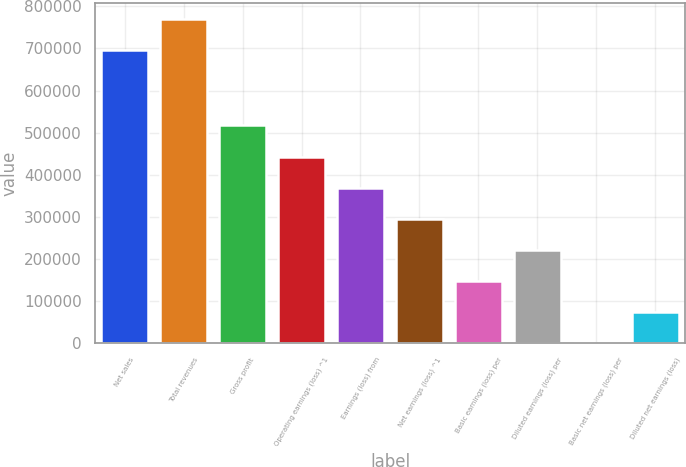Convert chart to OTSL. <chart><loc_0><loc_0><loc_500><loc_500><bar_chart><fcel>Net sales<fcel>Total revenues<fcel>Gross profit<fcel>Operating earnings (loss) ^1<fcel>Earnings (loss) from<fcel>Net earnings (loss) ^1<fcel>Basic earnings (loss) per<fcel>Diluted earnings (loss) per<fcel>Basic net earnings (loss) per<fcel>Diluted net earnings (loss)<nl><fcel>696078<fcel>769951<fcel>517113<fcel>443240<fcel>369367<fcel>295493<fcel>147747<fcel>221620<fcel>0.22<fcel>73873.5<nl></chart> 